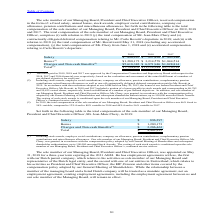According to Stmicroelectronics's financial document, What is approving authority of paid bonus? The bonus paid in 2019, 2018 and 2017 was approved by the compensation Committee and Supervisory Board. The document states: "(1) The bonus paid in 2019, 2018 and 2017 was approved by the Compensation Committee and Supervisory Board with respect to the 2018, 2017 and 2016 fin..." Also, What was the total compensation of the sole member of our Managing Board, President and Chief Executive Officer in 2019? 46% fixed to 54% variable. The document states: "Board, President and Chief Executive Officer was 46% fixed to 54% variable, compared to 12% fixed to 88% variable in 2018 and 44% fixed to 56% variabl..." Also, What was the total compensation of the sole member of our Managing Board, President and Chief Executive Officer in 2018? 12% fixed to 88% variable. The document states: "fficer was 46% fixed to 54% variable, compared to 12% fixed to 88% variable in 2018 and 44% fixed to 56% variable in 2017...." Also, can you calculate: What is the increase/ (decrease) in Salary from the period 2017 to 2018? Based on the calculation: 927,820-903,186, the result is 24634. This is based on the information: "Salary $ 896,297 $ 927,820 $ 903,186 Salary $ 896,297 $ 927,820 $ 903,186..." The key data points involved are: 903,186, 927,820. Also, can you calculate: What is the increase/ (decrease) in Bonus from the period 2017 to 2018? Based on the calculation: 3,214,578-1,044,514, the result is 2170064. This is based on the information: "Bonus (1) $1,280,173 $ 3,214,578 $1,044,514 Bonus (1) $1,280,173 $ 3,214,578 $1,044,514..." The key data points involved are: 1,044,514, 3,214,578. Also, can you calculate: What is the increase/ (decrease) in Charges and Non-cash Benefits from the period 2017 to 2018? Based on the calculation: 6,971,946-1,828,814, the result is 5143132. This is based on the information: "Charges and Non-cash Benefits (2) $5,618,382 $ 6,971,946 $1,828,814 and Non-cash Benefits (2) $5,618,382 $ 6,971,946 $1,828,814..." The key data points involved are: 1,828,814, 6,971,946. 